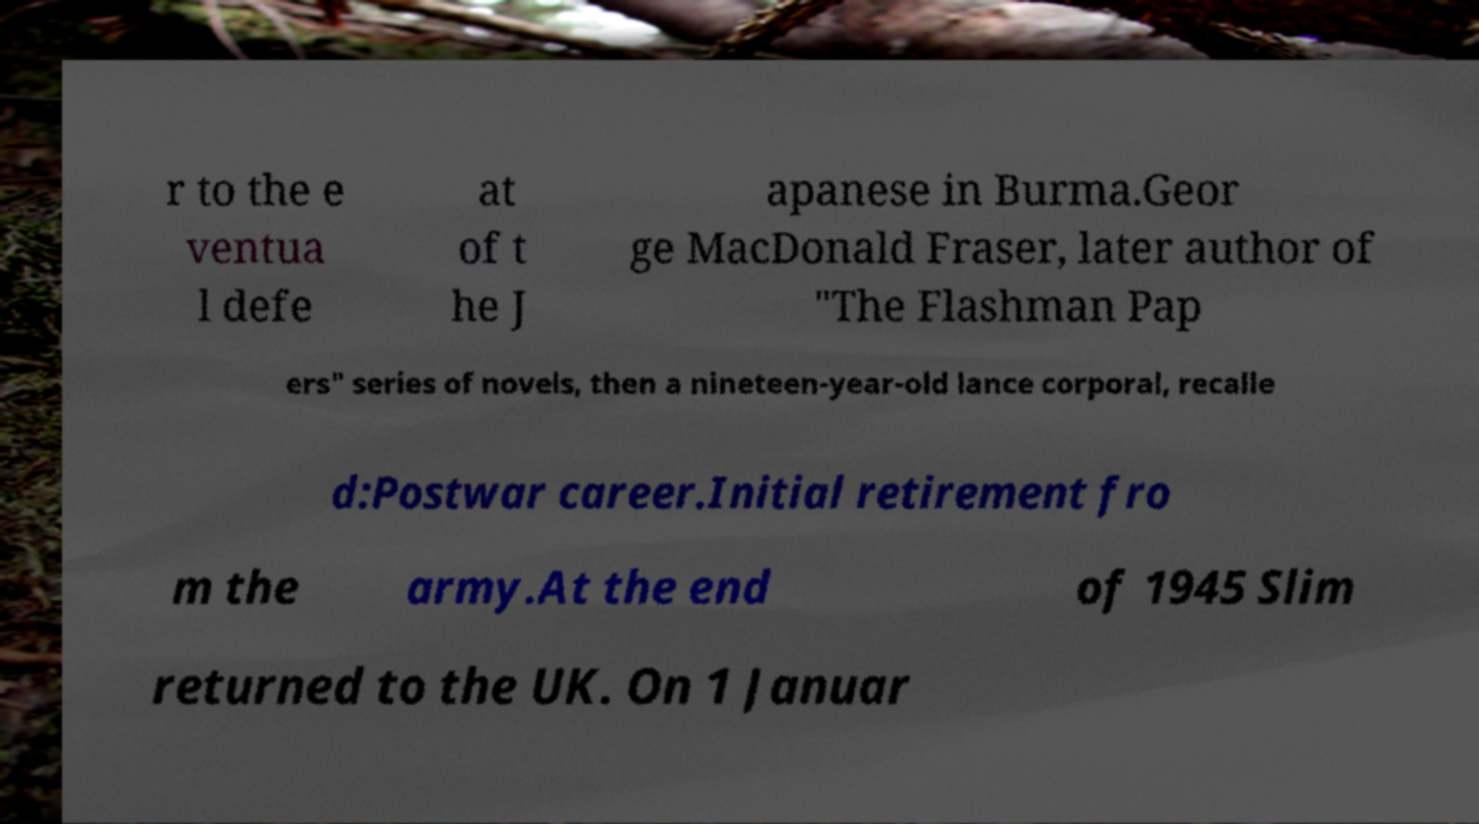Can you read and provide the text displayed in the image?This photo seems to have some interesting text. Can you extract and type it out for me? r to the e ventua l defe at of t he J apanese in Burma.Geor ge MacDonald Fraser, later author of "The Flashman Pap ers" series of novels, then a nineteen-year-old lance corporal, recalle d:Postwar career.Initial retirement fro m the army.At the end of 1945 Slim returned to the UK. On 1 Januar 